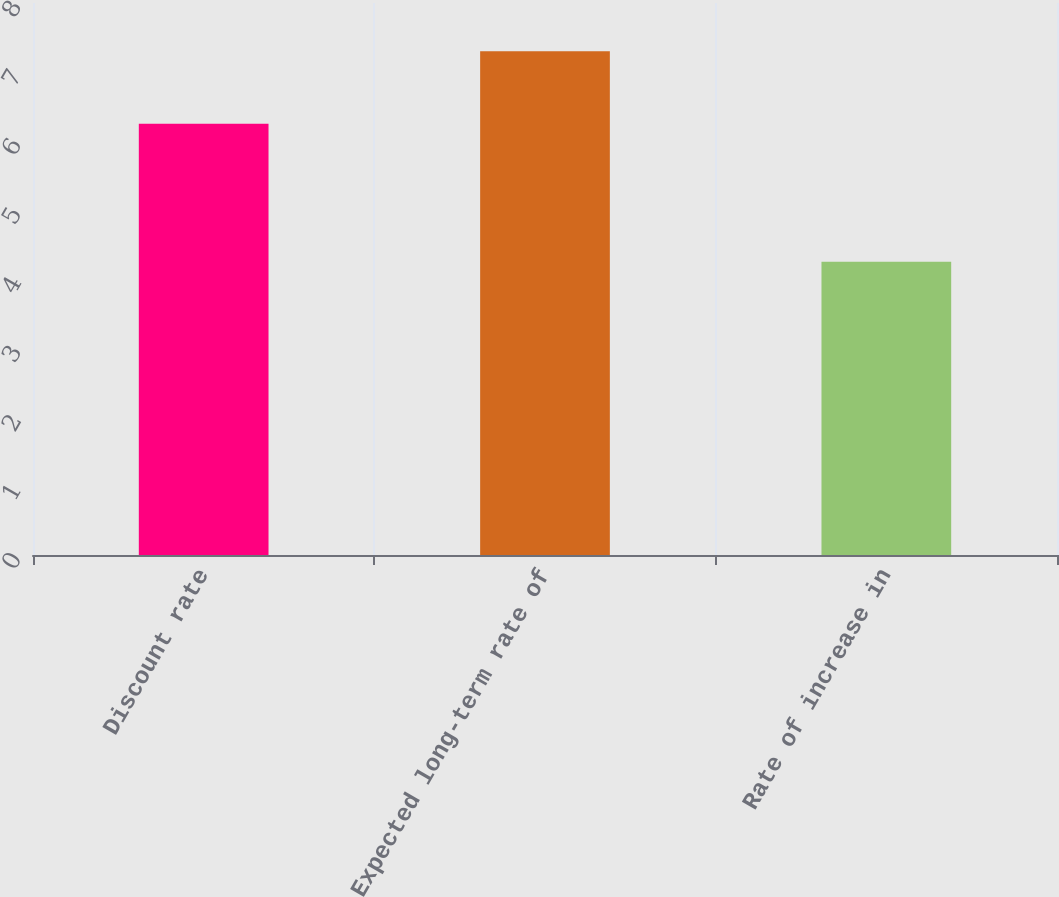Convert chart. <chart><loc_0><loc_0><loc_500><loc_500><bar_chart><fcel>Discount rate<fcel>Expected long-term rate of<fcel>Rate of increase in<nl><fcel>6.25<fcel>7.3<fcel>4.25<nl></chart> 